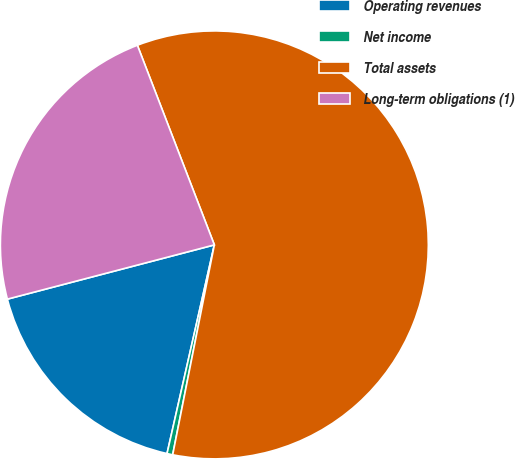Convert chart. <chart><loc_0><loc_0><loc_500><loc_500><pie_chart><fcel>Operating revenues<fcel>Net income<fcel>Total assets<fcel>Long-term obligations (1)<nl><fcel>17.37%<fcel>0.43%<fcel>58.97%<fcel>23.22%<nl></chart> 